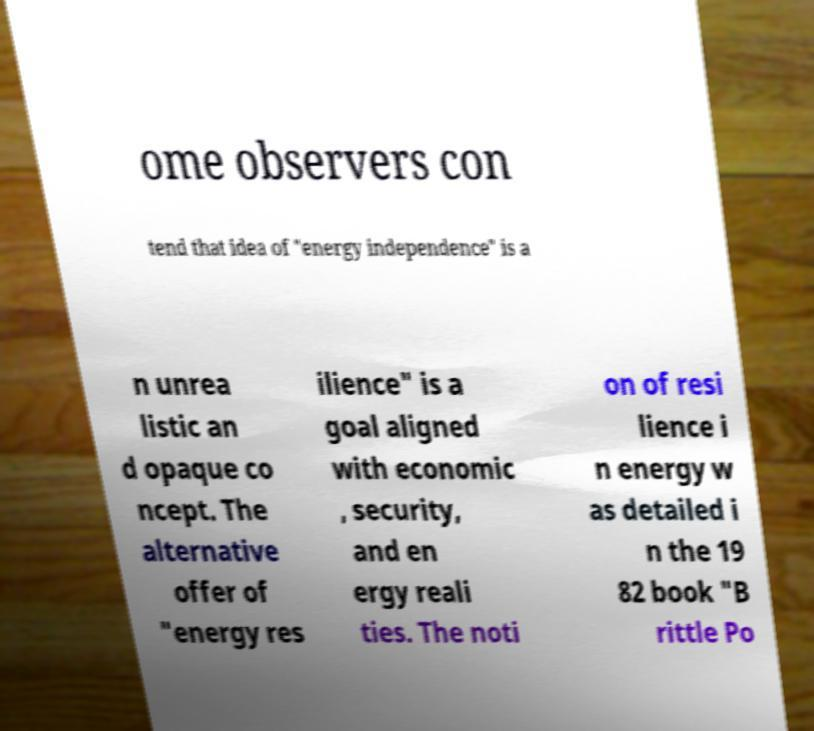Please read and relay the text visible in this image. What does it say? ome observers con tend that idea of "energy independence" is a n unrea listic an d opaque co ncept. The alternative offer of "energy res ilience" is a goal aligned with economic , security, and en ergy reali ties. The noti on of resi lience i n energy w as detailed i n the 19 82 book "B rittle Po 